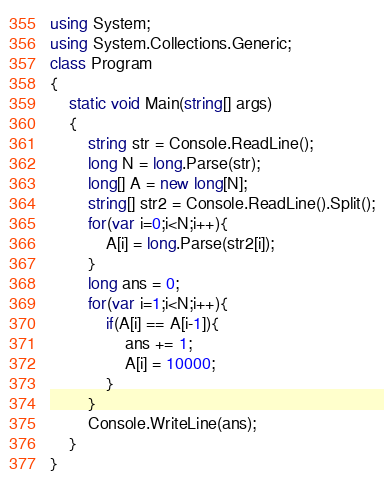Convert code to text. <code><loc_0><loc_0><loc_500><loc_500><_C#_>using System;
using System.Collections.Generic;
class Program
{
	static void Main(string[] args)
	{
		string str = Console.ReadLine();
		long N = long.Parse(str);
		long[] A = new long[N];
		string[] str2 = Console.ReadLine().Split();
		for(var i=0;i<N;i++){
			A[i] = long.Parse(str2[i]);
		}
		long ans = 0;
		for(var i=1;i<N;i++){
			if(A[i] == A[i-1]){
				ans += 1;
				A[i] = 10000;
			}
		}
		Console.WriteLine(ans);
	}
}</code> 